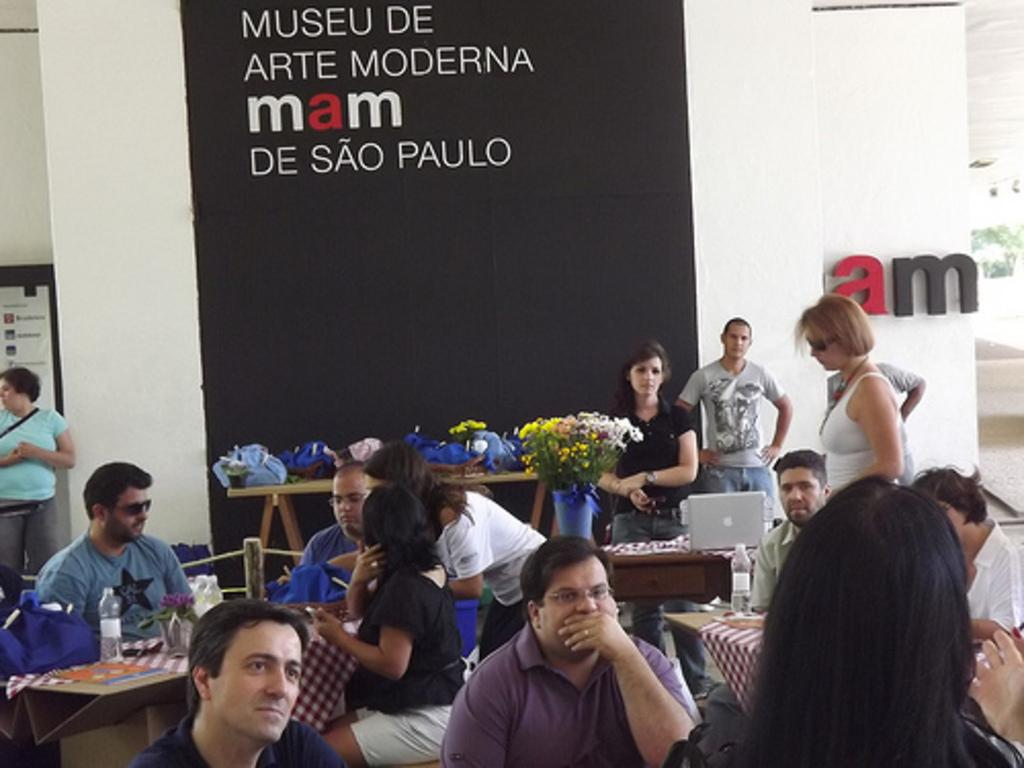How many people are in the image? There is a group of people in the image. What are the people doing in the image? The people are sitting on chairs. Where are the chairs located in relation to the table? The chairs are in front of a table. What can be seen on the table in the image? There is a glass bottle, a laptop, and other objects on the table. Are there any fairies visible in the image? No, there are no fairies present in the image. What type of error can be seen on the laptop screen in the image? There is no laptop screen visible in the image, so it is not possible to determine if there is an error present. 